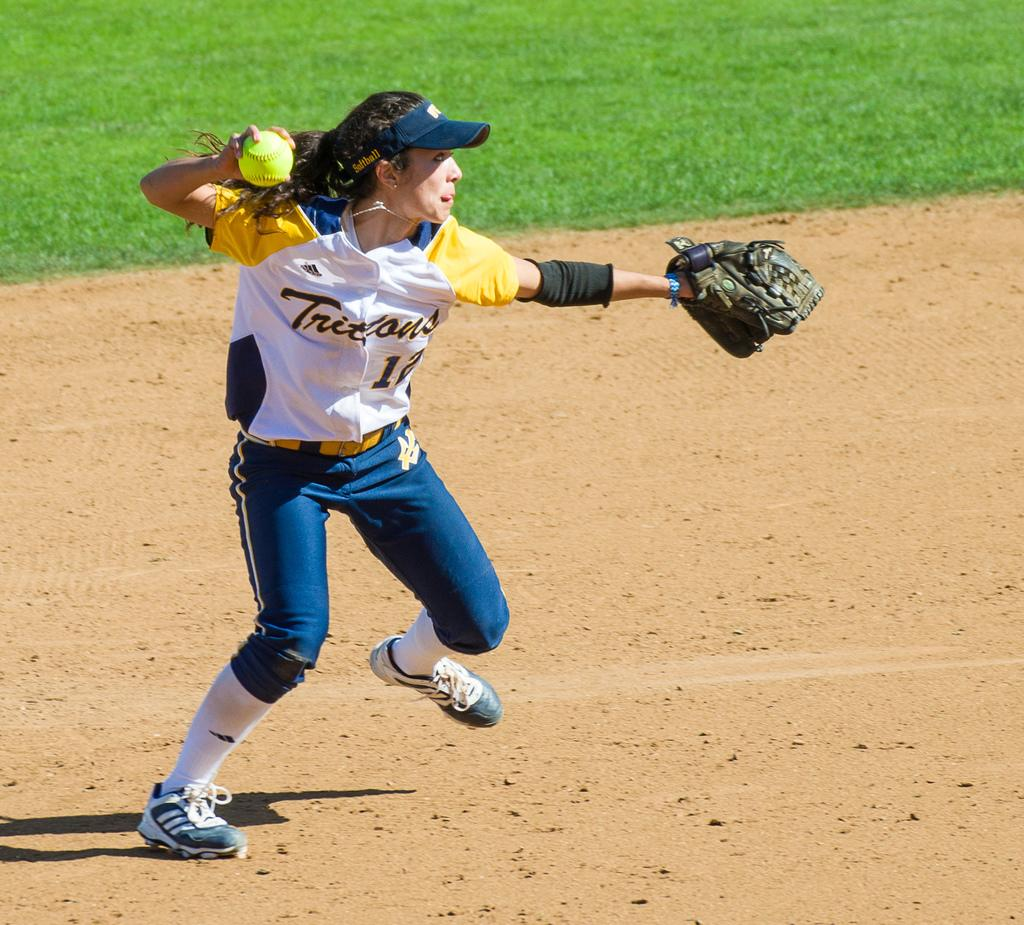Who is the main subject in the image? There is a lady in the image. What type of clothing is the lady wearing? The lady is wearing a sports dress. What accessories is the lady wearing? The lady is wearing a glove and a cap. What object is the lady holding in the image? The lady is holding a ball. What type of surface is visible at the bottom of the image? There is ground visible at the bottom of the image. How many dogs are present in the image? There are no dogs present in the image. What type of base is supporting the lady in the image? The lady is standing on the ground, and there is no additional base supporting her. 